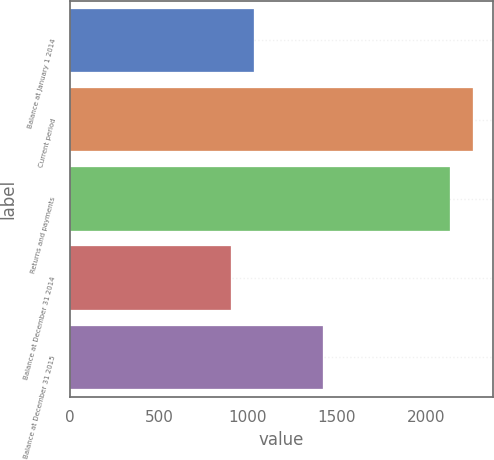Convert chart. <chart><loc_0><loc_0><loc_500><loc_500><bar_chart><fcel>Balance at January 1 2014<fcel>Current period<fcel>Returns and payments<fcel>Balance at December 31 2014<fcel>Balance at December 31 2015<nl><fcel>1036.2<fcel>2263.2<fcel>2134<fcel>907<fcel>1421<nl></chart> 